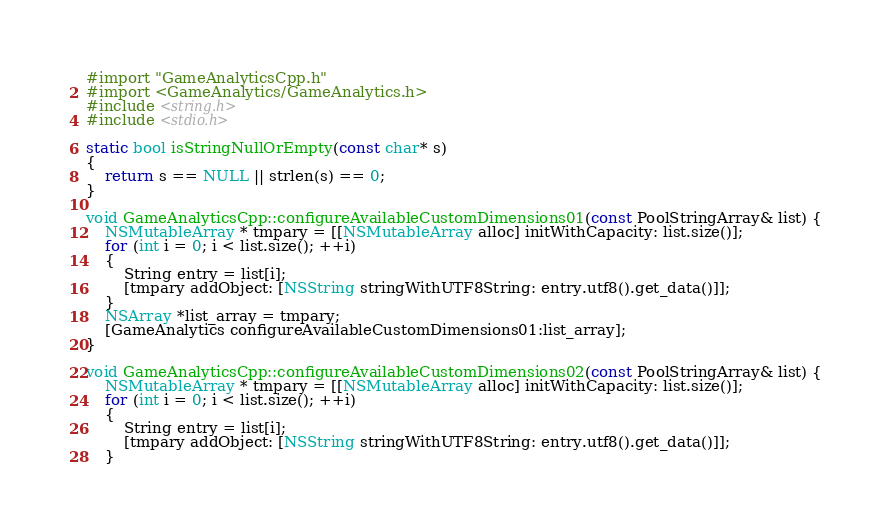<code> <loc_0><loc_0><loc_500><loc_500><_ObjectiveC_>#import "GameAnalyticsCpp.h"
#import <GameAnalytics/GameAnalytics.h>
#include <string.h>
#include <stdio.h>

static bool isStringNullOrEmpty(const char* s)
{
    return s == NULL || strlen(s) == 0;
}

void GameAnalyticsCpp::configureAvailableCustomDimensions01(const PoolStringArray& list) {
    NSMutableArray * tmpary = [[NSMutableArray alloc] initWithCapacity: list.size()];
    for (int i = 0; i < list.size(); ++i)
    {
        String entry = list[i];
        [tmpary addObject: [NSString stringWithUTF8String: entry.utf8().get_data()]];
    }
    NSArray *list_array = tmpary;
    [GameAnalytics configureAvailableCustomDimensions01:list_array];
}

void GameAnalyticsCpp::configureAvailableCustomDimensions02(const PoolStringArray& list) {
    NSMutableArray * tmpary = [[NSMutableArray alloc] initWithCapacity: list.size()];
    for (int i = 0; i < list.size(); ++i)
    {
        String entry = list[i];
        [tmpary addObject: [NSString stringWithUTF8String: entry.utf8().get_data()]];
    }</code> 